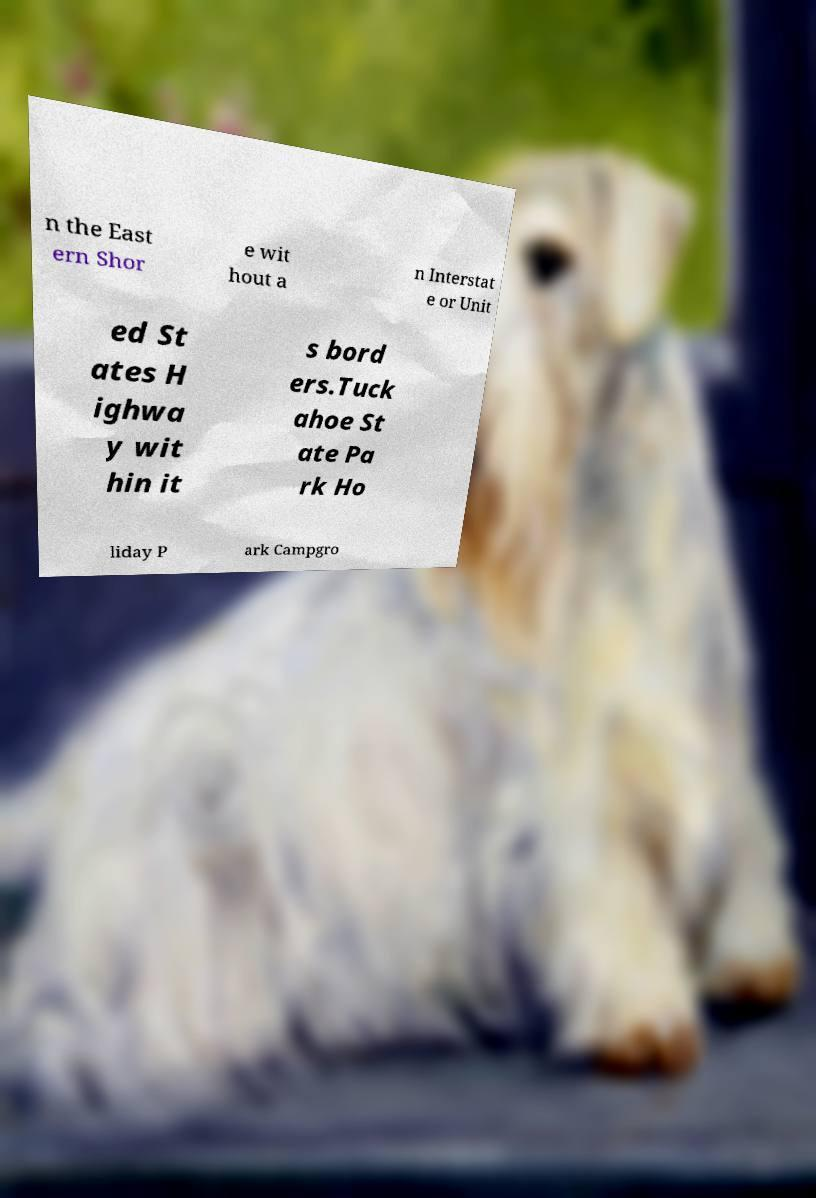Please identify and transcribe the text found in this image. n the East ern Shor e wit hout a n Interstat e or Unit ed St ates H ighwa y wit hin it s bord ers.Tuck ahoe St ate Pa rk Ho liday P ark Campgro 